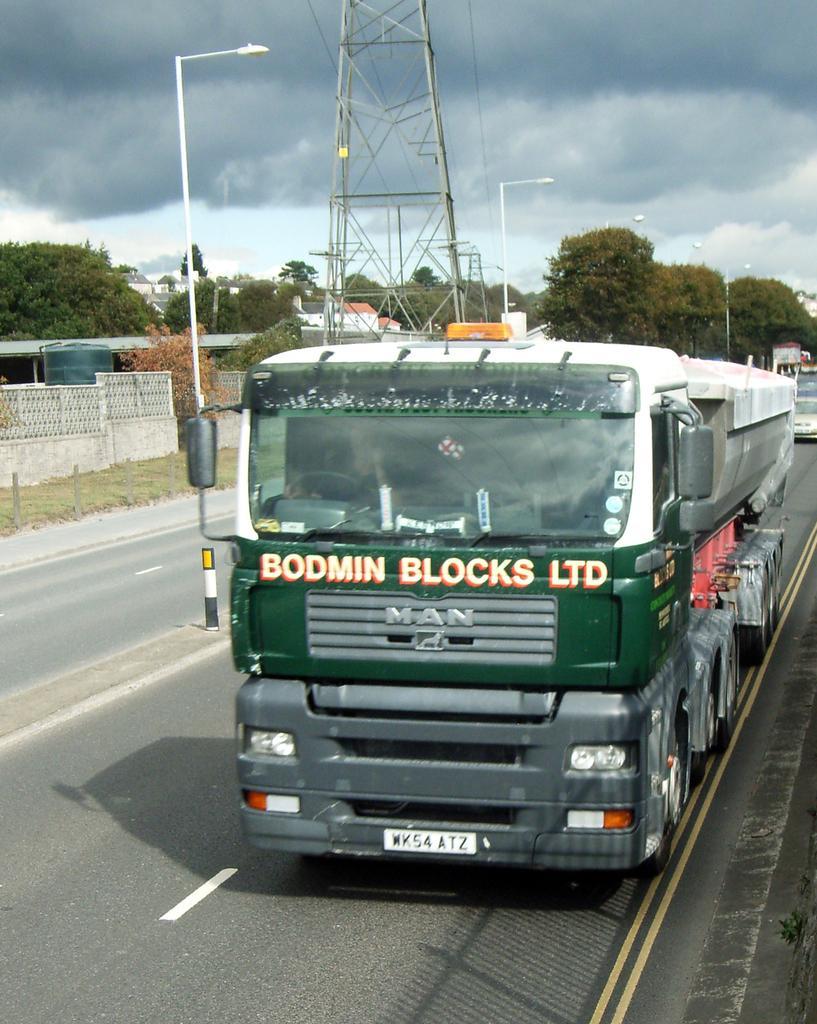How would you summarize this image in a sentence or two? In this image I can see the road. On the road there are many vehicles. To the side of the road I can see the light poles and the wall. In the background there are many trees, clouds and the sky. I can also see the tower in the back. 